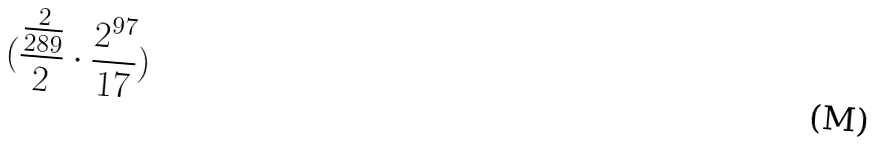Convert formula to latex. <formula><loc_0><loc_0><loc_500><loc_500>( \frac { \frac { 2 } { 2 8 9 } } { 2 } \cdot \frac { 2 ^ { 9 7 } } { 1 7 } )</formula> 